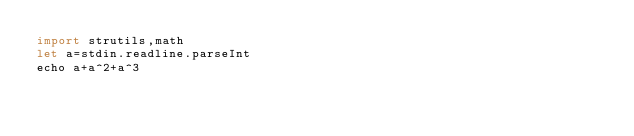Convert code to text. <code><loc_0><loc_0><loc_500><loc_500><_Nim_>import strutils,math
let a=stdin.readline.parseInt
echo a+a^2+a^3</code> 